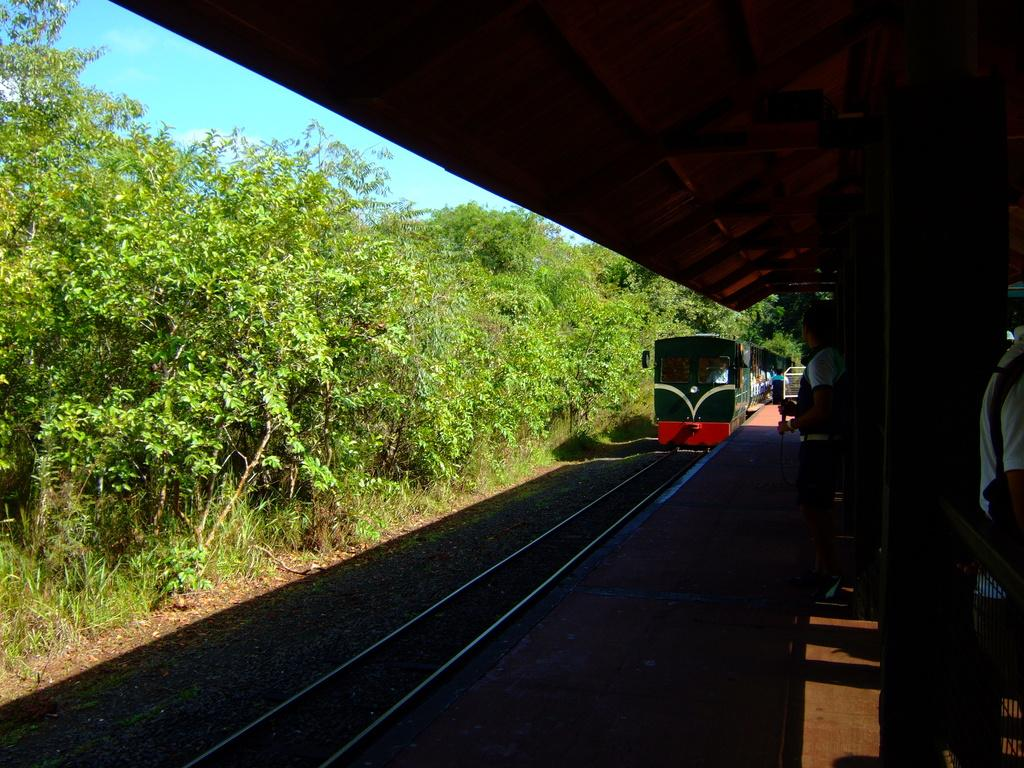What is the main subject of the image? There is a train in the image. Where is the train located? The train is on a train track. What type of vegetation can be seen in the image? There is grass and trees visible in the image. What is the color of the sky in the image? The sky is pale blue in the image. Are there any people present in the image? Yes, there are people wearing clothes in the image. What type of lunchroom can be seen in the image? There is no lunchroom present in the image; it features a train on a train track with surrounding vegetation and people. 